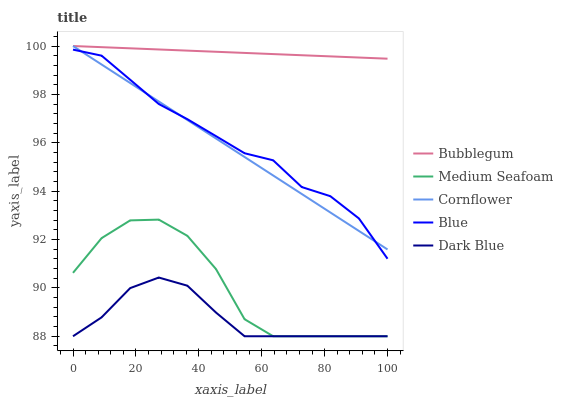Does Dark Blue have the minimum area under the curve?
Answer yes or no. Yes. Does Bubblegum have the maximum area under the curve?
Answer yes or no. Yes. Does Cornflower have the minimum area under the curve?
Answer yes or no. No. Does Cornflower have the maximum area under the curve?
Answer yes or no. No. Is Cornflower the smoothest?
Answer yes or no. Yes. Is Medium Seafoam the roughest?
Answer yes or no. Yes. Is Medium Seafoam the smoothest?
Answer yes or no. No. Is Cornflower the roughest?
Answer yes or no. No. Does Medium Seafoam have the lowest value?
Answer yes or no. Yes. Does Cornflower have the lowest value?
Answer yes or no. No. Does Bubblegum have the highest value?
Answer yes or no. Yes. Does Medium Seafoam have the highest value?
Answer yes or no. No. Is Medium Seafoam less than Blue?
Answer yes or no. Yes. Is Bubblegum greater than Blue?
Answer yes or no. Yes. Does Blue intersect Cornflower?
Answer yes or no. Yes. Is Blue less than Cornflower?
Answer yes or no. No. Is Blue greater than Cornflower?
Answer yes or no. No. Does Medium Seafoam intersect Blue?
Answer yes or no. No. 